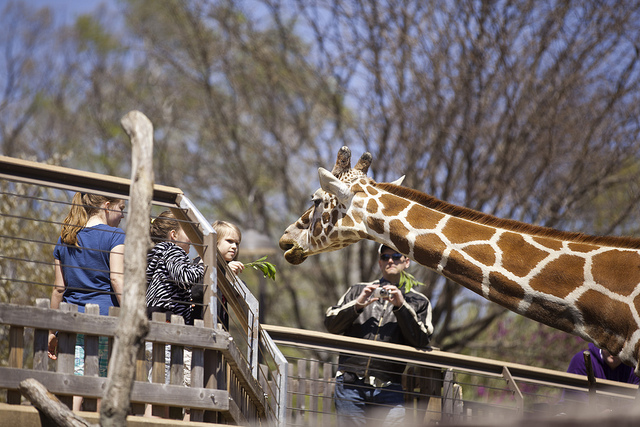How many people can be seen? There are three people in the photograph, engaging with a giraffe at what appears to be a zoo or wildlife park. One individual is taking pictures of the interaction, capturing a memorable experience. 